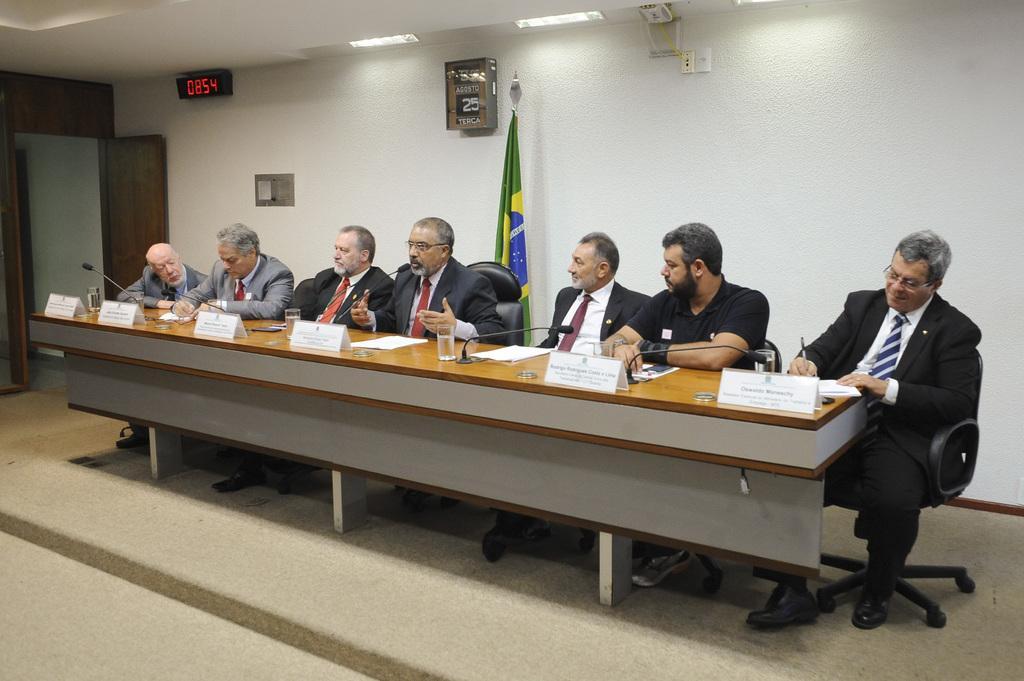In one or two sentences, can you explain what this image depicts? This picture shows few men seated on the chair and we see glasses and some papers and microphones on the table and we see a man speaking with the help of a microphone and we see flag on their back and a frame to the wall and we see a digital clock and few men wore coats and ties to their necks and couple of them wore spectacles on their faces. 